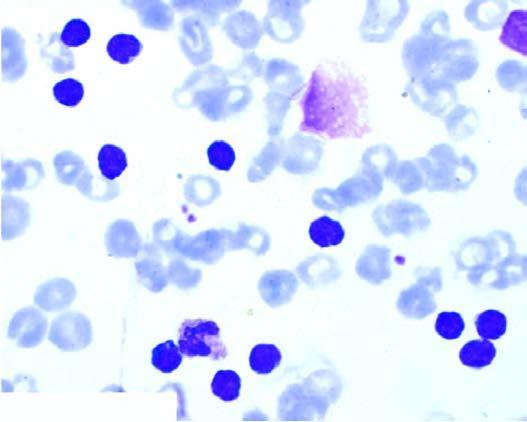what is there?
Answer the question using a single word or phrase. Large excess of mature and small differentiated lymphocytes 